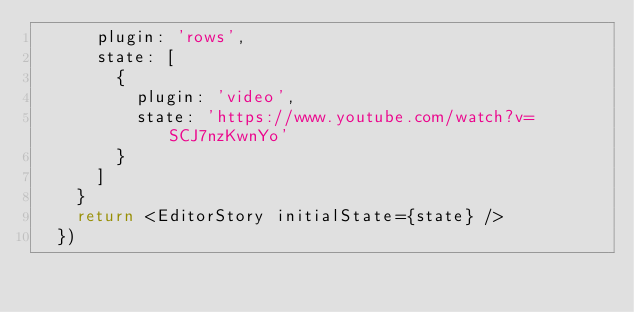Convert code to text. <code><loc_0><loc_0><loc_500><loc_500><_TypeScript_>      plugin: 'rows',
      state: [
        {
          plugin: 'video',
          state: 'https://www.youtube.com/watch?v=SCJ7nzKwnYo'
        }
      ]
    }
    return <EditorStory initialState={state} />
  })
</code> 